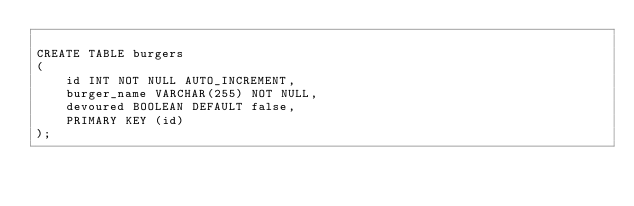Convert code to text. <code><loc_0><loc_0><loc_500><loc_500><_SQL_>
CREATE TABLE burgers 
(
    id INT NOT NULL AUTO_INCREMENT,
    burger_name VARCHAR(255) NOT NULL,
    devoured BOOLEAN DEFAULT false,
    PRIMARY KEY (id) 
);</code> 